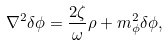<formula> <loc_0><loc_0><loc_500><loc_500>\nabla ^ { 2 } \delta \phi = \frac { 2 \zeta } { \omega } \rho + m _ { \phi } ^ { 2 } \delta \phi ,</formula> 